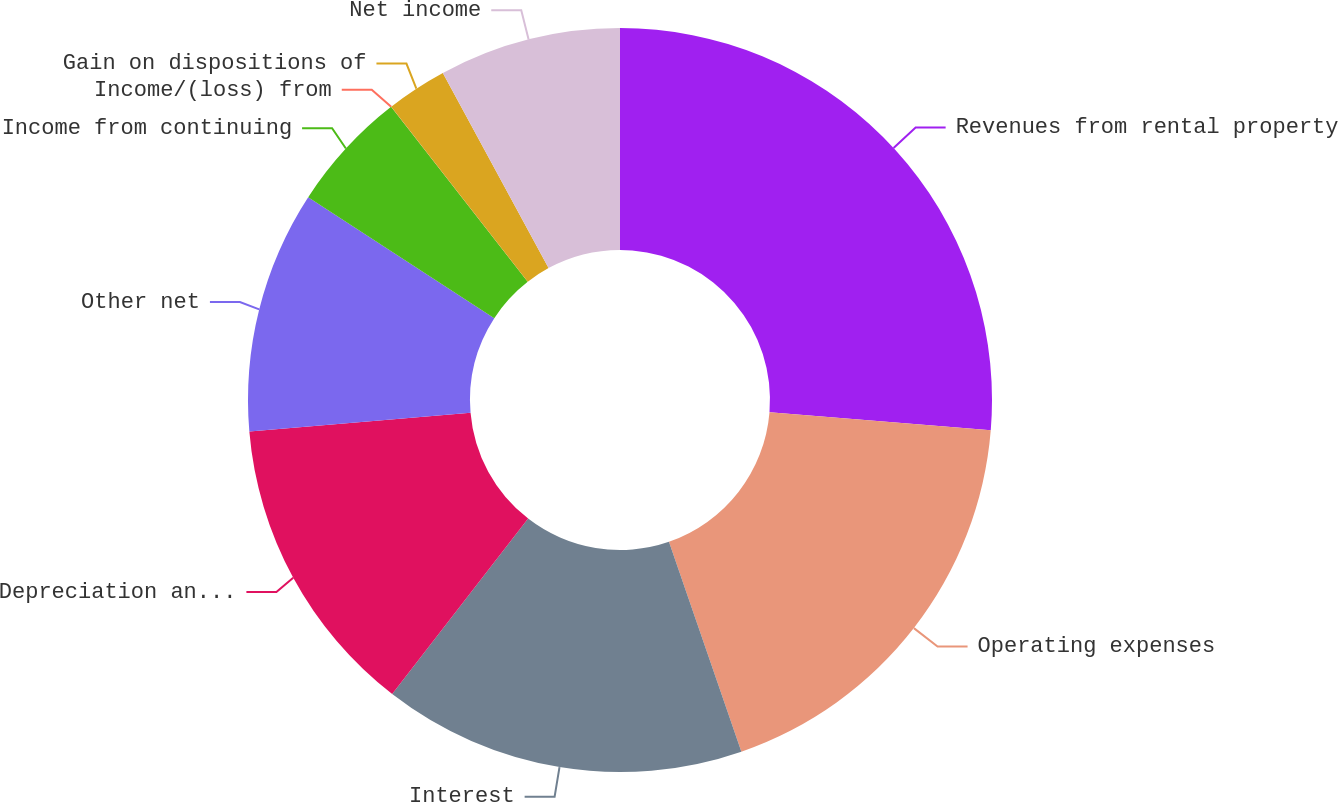Convert chart to OTSL. <chart><loc_0><loc_0><loc_500><loc_500><pie_chart><fcel>Revenues from rental property<fcel>Operating expenses<fcel>Interest<fcel>Depreciation and amortization<fcel>Other net<fcel>Income from continuing<fcel>Income/(loss) from<fcel>Gain on dispositions of<fcel>Net income<nl><fcel>26.3%<fcel>18.41%<fcel>15.78%<fcel>13.16%<fcel>10.53%<fcel>5.27%<fcel>0.01%<fcel>2.64%<fcel>7.9%<nl></chart> 